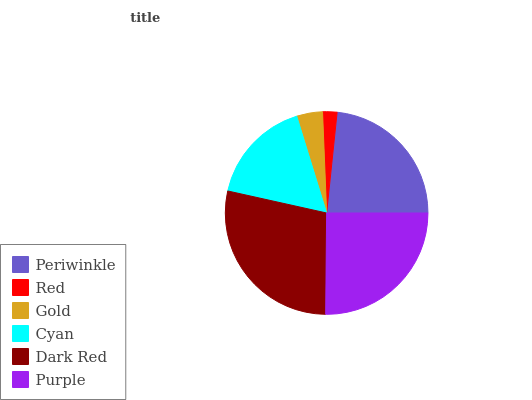Is Red the minimum?
Answer yes or no. Yes. Is Dark Red the maximum?
Answer yes or no. Yes. Is Gold the minimum?
Answer yes or no. No. Is Gold the maximum?
Answer yes or no. No. Is Gold greater than Red?
Answer yes or no. Yes. Is Red less than Gold?
Answer yes or no. Yes. Is Red greater than Gold?
Answer yes or no. No. Is Gold less than Red?
Answer yes or no. No. Is Periwinkle the high median?
Answer yes or no. Yes. Is Cyan the low median?
Answer yes or no. Yes. Is Red the high median?
Answer yes or no. No. Is Dark Red the low median?
Answer yes or no. No. 